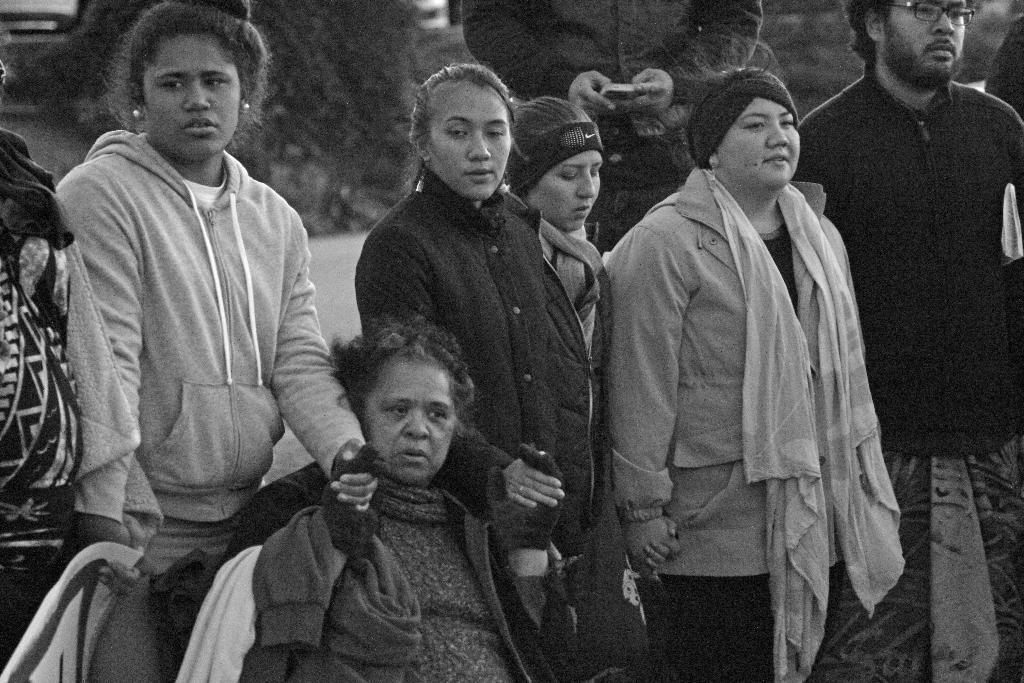Can you describe this image briefly? This is a black and white image. People are standing and holding hands of each other. 